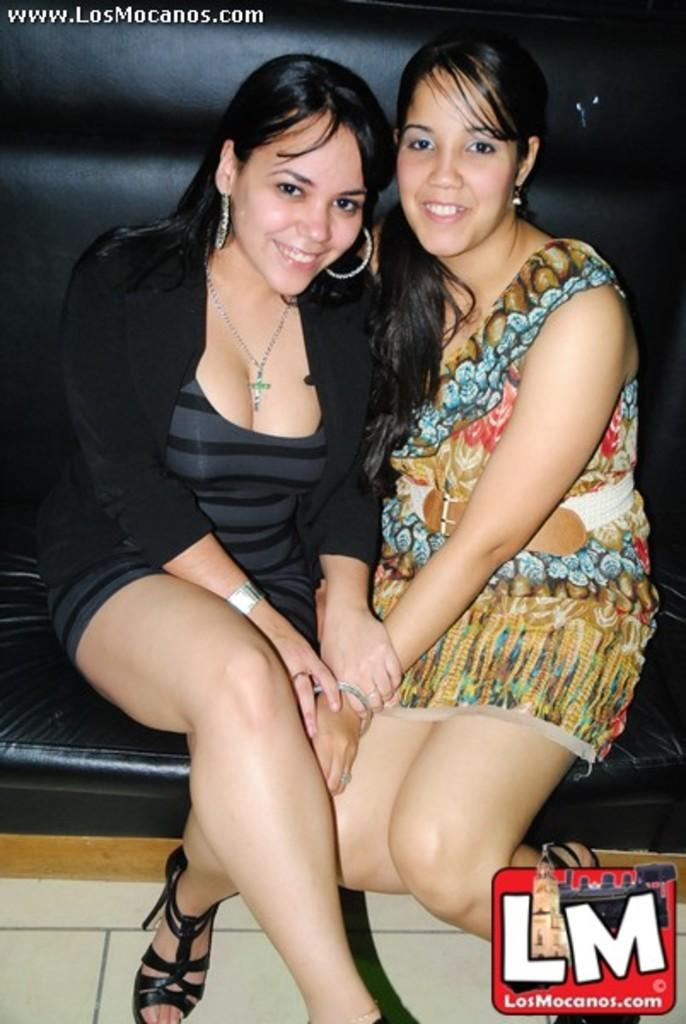How many people are in the image? There are two women in the image. What are the women doing in the image? The women are sitting on a couch and smiling. What can be seen beneath the women in the image? There is a floor visible in the image. Is there any branding or identification in the image? Yes, there is a logo in the bottom right corner of the image. What type of muscle is being flexed by the women in the image? There is no muscle flexing depicted in the image; the women are sitting and smiling. 